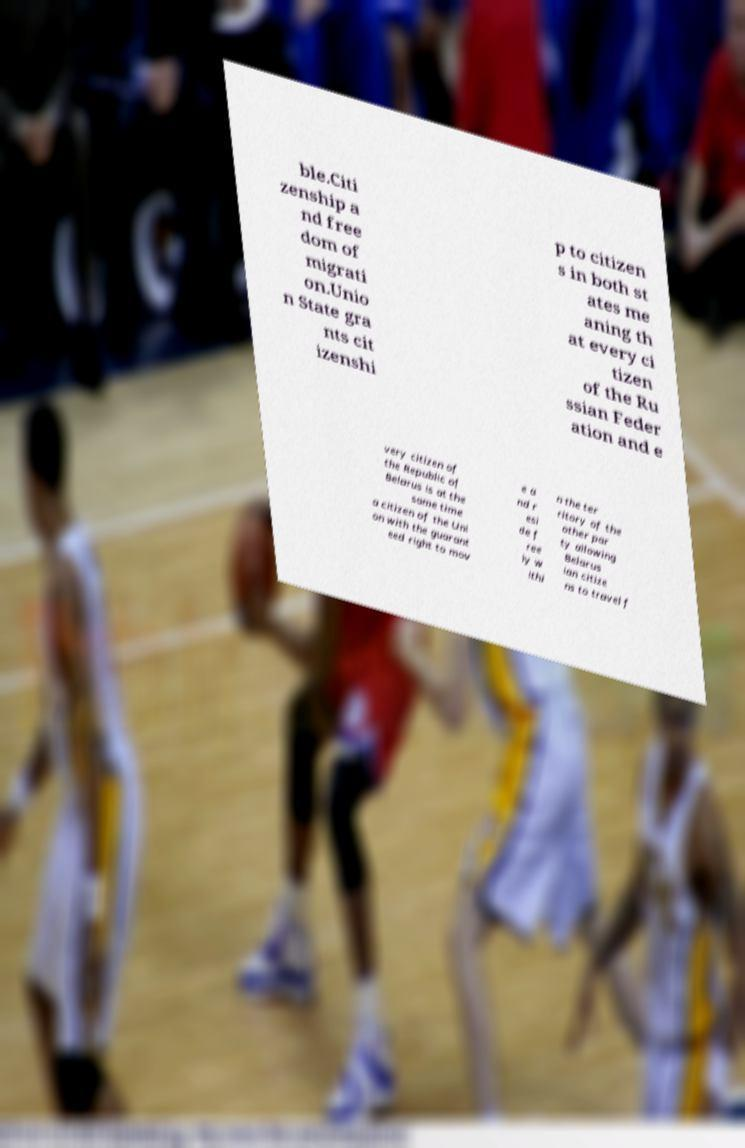There's text embedded in this image that I need extracted. Can you transcribe it verbatim? ble.Citi zenship a nd free dom of migrati on.Unio n State gra nts cit izenshi p to citizen s in both st ates me aning th at every ci tizen of the Ru ssian Feder ation and e very citizen of the Republic of Belarus is at the same time a citizen of the Uni on with the guarant eed right to mov e a nd r esi de f ree ly w ithi n the ter ritory of the other par ty allowing Belarus ian citize ns to travel f 